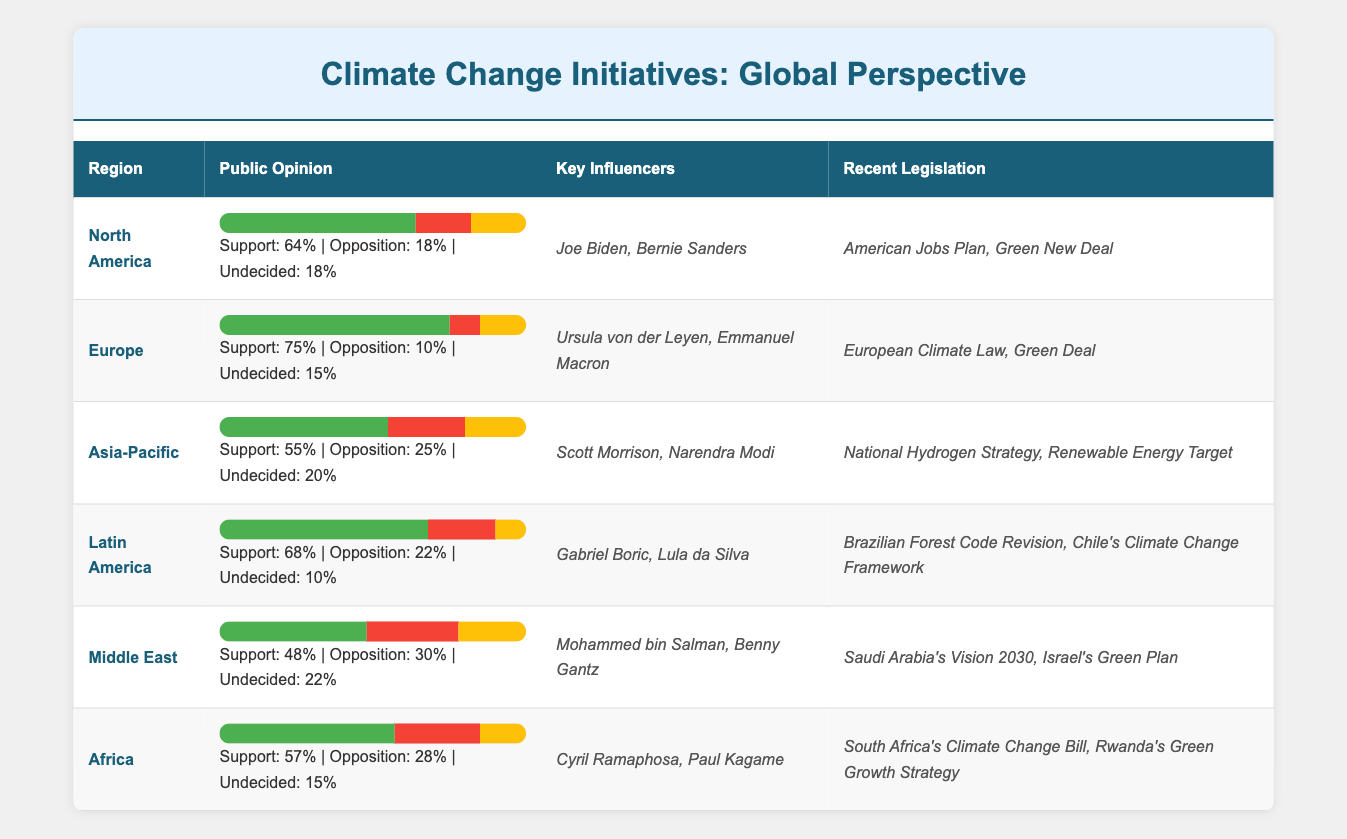What is the public support percentage for climate change initiatives in North America? The table indicates that in the North America region, the public support percentage is explicitly stated to be 64%.
Answer: 64% Which region has the highest public support percentage for climate change initiatives? By comparing the public support percentages across all regions, Europe has the highest figure at 75%.
Answer: Europe What is the average public support percentage across all regions listed? The public support percentages are 64, 75, 55, 68, 48, and 57. Adding them gives 64 + 75 + 55 + 68 + 48 + 57 = 367. There are 6 regions, so the average is 367 / 6 = 61.17, which rounds to 61.
Answer: 61 Is the opposition percentage in Asia-Pacific greater than that in Latin America? The opposition percentage for Asia-Pacific is 25%, and for Latin America, it is 22%. Since 25% is greater than 22%, the statement is true.
Answer: Yes How many regions have a public support percentage above 60%? Looking at the table, the regions North America (64%), Europe (75%), and Latin America (68%) all have support percentages above 60%. This totals to three regions.
Answer: 3 What is the difference in public support percentage between Europe and the Middle East? The public support percentage for Europe is 75%, while for the Middle East, it is 48%. The difference is 75 - 48 = 27.
Answer: 27 Do any regions have an opposition percentage of 30% or higher? The Middle East has an opposition percentage of 30%. All other regions have lower opposition percentages, confirming that at least one region meets this criterion.
Answer: Yes Which region has the least public support for climate change initiatives? By examining the public support percentages, the Middle East with 48% has the lowest support.
Answer: Middle East 